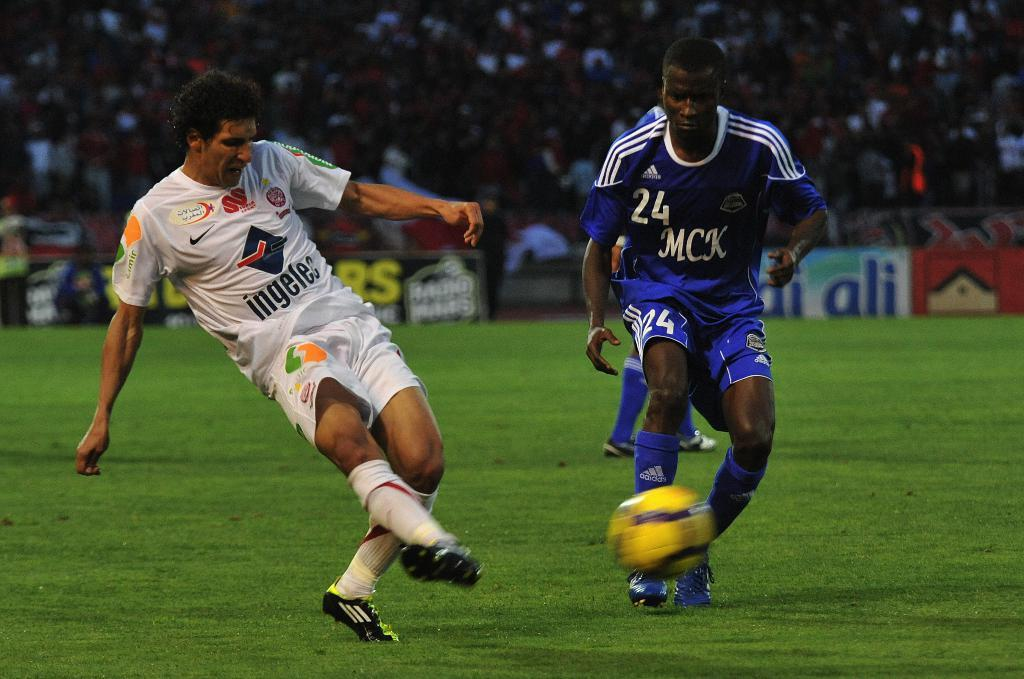What is the main activity taking place in the image? People are playing football on the ground. What color is the football being used in the game? The football is yellow. Can you describe the people in the background of the image? There is a crowd in the background watching the game. Where is the stove located in the image? There is no stove present in the image. What type of degree do the players have in the game? The image does not provide information about the players' degrees. 